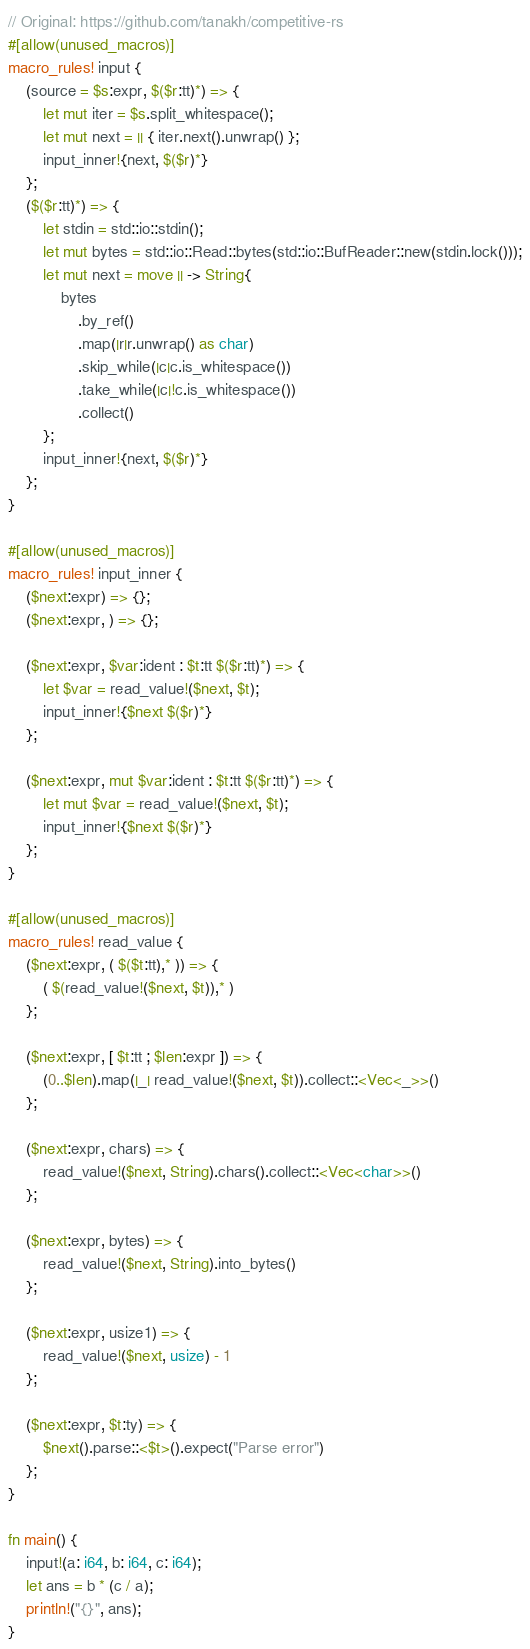<code> <loc_0><loc_0><loc_500><loc_500><_Rust_>// Original: https://github.com/tanakh/competitive-rs
#[allow(unused_macros)]
macro_rules! input {
    (source = $s:expr, $($r:tt)*) => {
        let mut iter = $s.split_whitespace();
        let mut next = || { iter.next().unwrap() };
        input_inner!{next, $($r)*}
    };
    ($($r:tt)*) => {
        let stdin = std::io::stdin();
        let mut bytes = std::io::Read::bytes(std::io::BufReader::new(stdin.lock()));
        let mut next = move || -> String{
            bytes
                .by_ref()
                .map(|r|r.unwrap() as char)
                .skip_while(|c|c.is_whitespace())
                .take_while(|c|!c.is_whitespace())
                .collect()
        };
        input_inner!{next, $($r)*}
    };
}

#[allow(unused_macros)]
macro_rules! input_inner {
    ($next:expr) => {};
    ($next:expr, ) => {};

    ($next:expr, $var:ident : $t:tt $($r:tt)*) => {
        let $var = read_value!($next, $t);
        input_inner!{$next $($r)*}
    };

    ($next:expr, mut $var:ident : $t:tt $($r:tt)*) => {
        let mut $var = read_value!($next, $t);
        input_inner!{$next $($r)*}
    };
}

#[allow(unused_macros)]
macro_rules! read_value {
    ($next:expr, ( $($t:tt),* )) => {
        ( $(read_value!($next, $t)),* )
    };

    ($next:expr, [ $t:tt ; $len:expr ]) => {
        (0..$len).map(|_| read_value!($next, $t)).collect::<Vec<_>>()
    };

    ($next:expr, chars) => {
        read_value!($next, String).chars().collect::<Vec<char>>()
    };

    ($next:expr, bytes) => {
        read_value!($next, String).into_bytes()
    };

    ($next:expr, usize1) => {
        read_value!($next, usize) - 1
    };

    ($next:expr, $t:ty) => {
        $next().parse::<$t>().expect("Parse error")
    };
}

fn main() {
    input!(a: i64, b: i64, c: i64);
    let ans = b * (c / a);
    println!("{}", ans);
}
</code> 